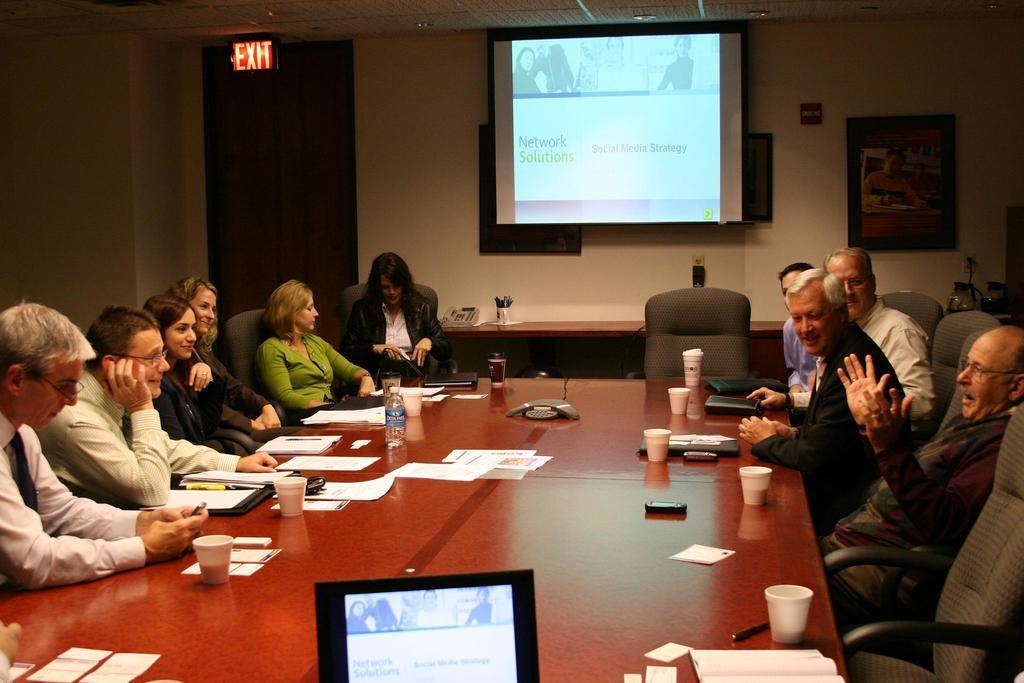Please provide a concise description of this image. It is a conference room, there are lot of people sitting around a table and the first person to the right side who is sitting is speaking something there are caps,papers and bottle and a tab on the table, straight to the table there is a projector , below the projector there is a table which has a cup and a telephone , behind the table there is a wall and a photo poster on the wall. To the left side of the wall there is a door and above it there is an exit board. 